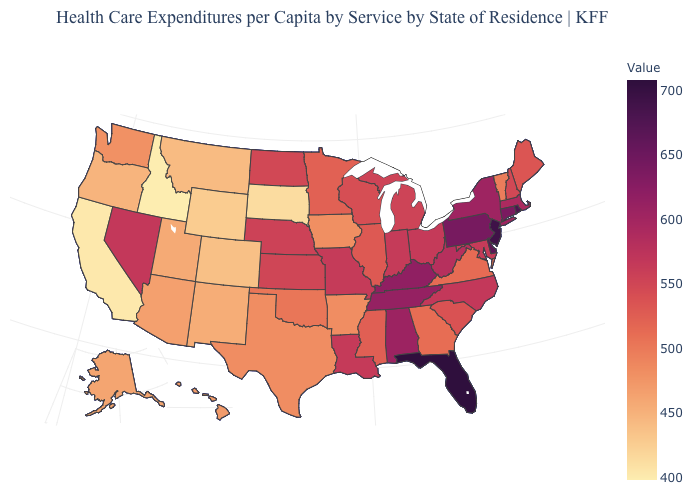Among the states that border Michigan , which have the highest value?
Quick response, please. Ohio. Does Idaho have the lowest value in the USA?
Keep it brief. Yes. 